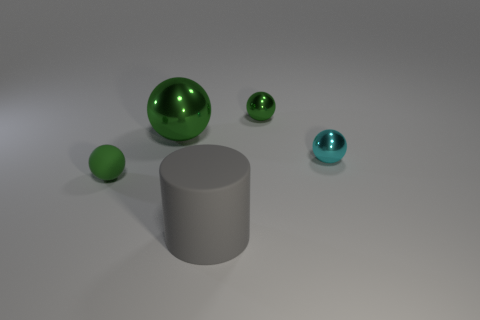What color is the rubber sphere that is the same size as the cyan object?
Make the answer very short. Green. What number of metallic things are the same shape as the tiny matte thing?
Offer a very short reply. 3. What is the color of the shiny ball that is to the left of the gray rubber object?
Give a very brief answer. Green. What number of metal objects are tiny purple blocks or big cylinders?
Keep it short and to the point. 0. The small shiny object that is the same color as the matte sphere is what shape?
Provide a succinct answer. Sphere. How many other objects have the same size as the gray matte object?
Keep it short and to the point. 1. There is a object that is both behind the small rubber sphere and left of the large gray cylinder; what color is it?
Ensure brevity in your answer.  Green. How many things are either small cyan metal objects or green things?
Your answer should be compact. 4. What number of tiny objects are green shiny objects or balls?
Your answer should be very brief. 3. Is there any other thing that is the same color as the matte cylinder?
Keep it short and to the point. No. 